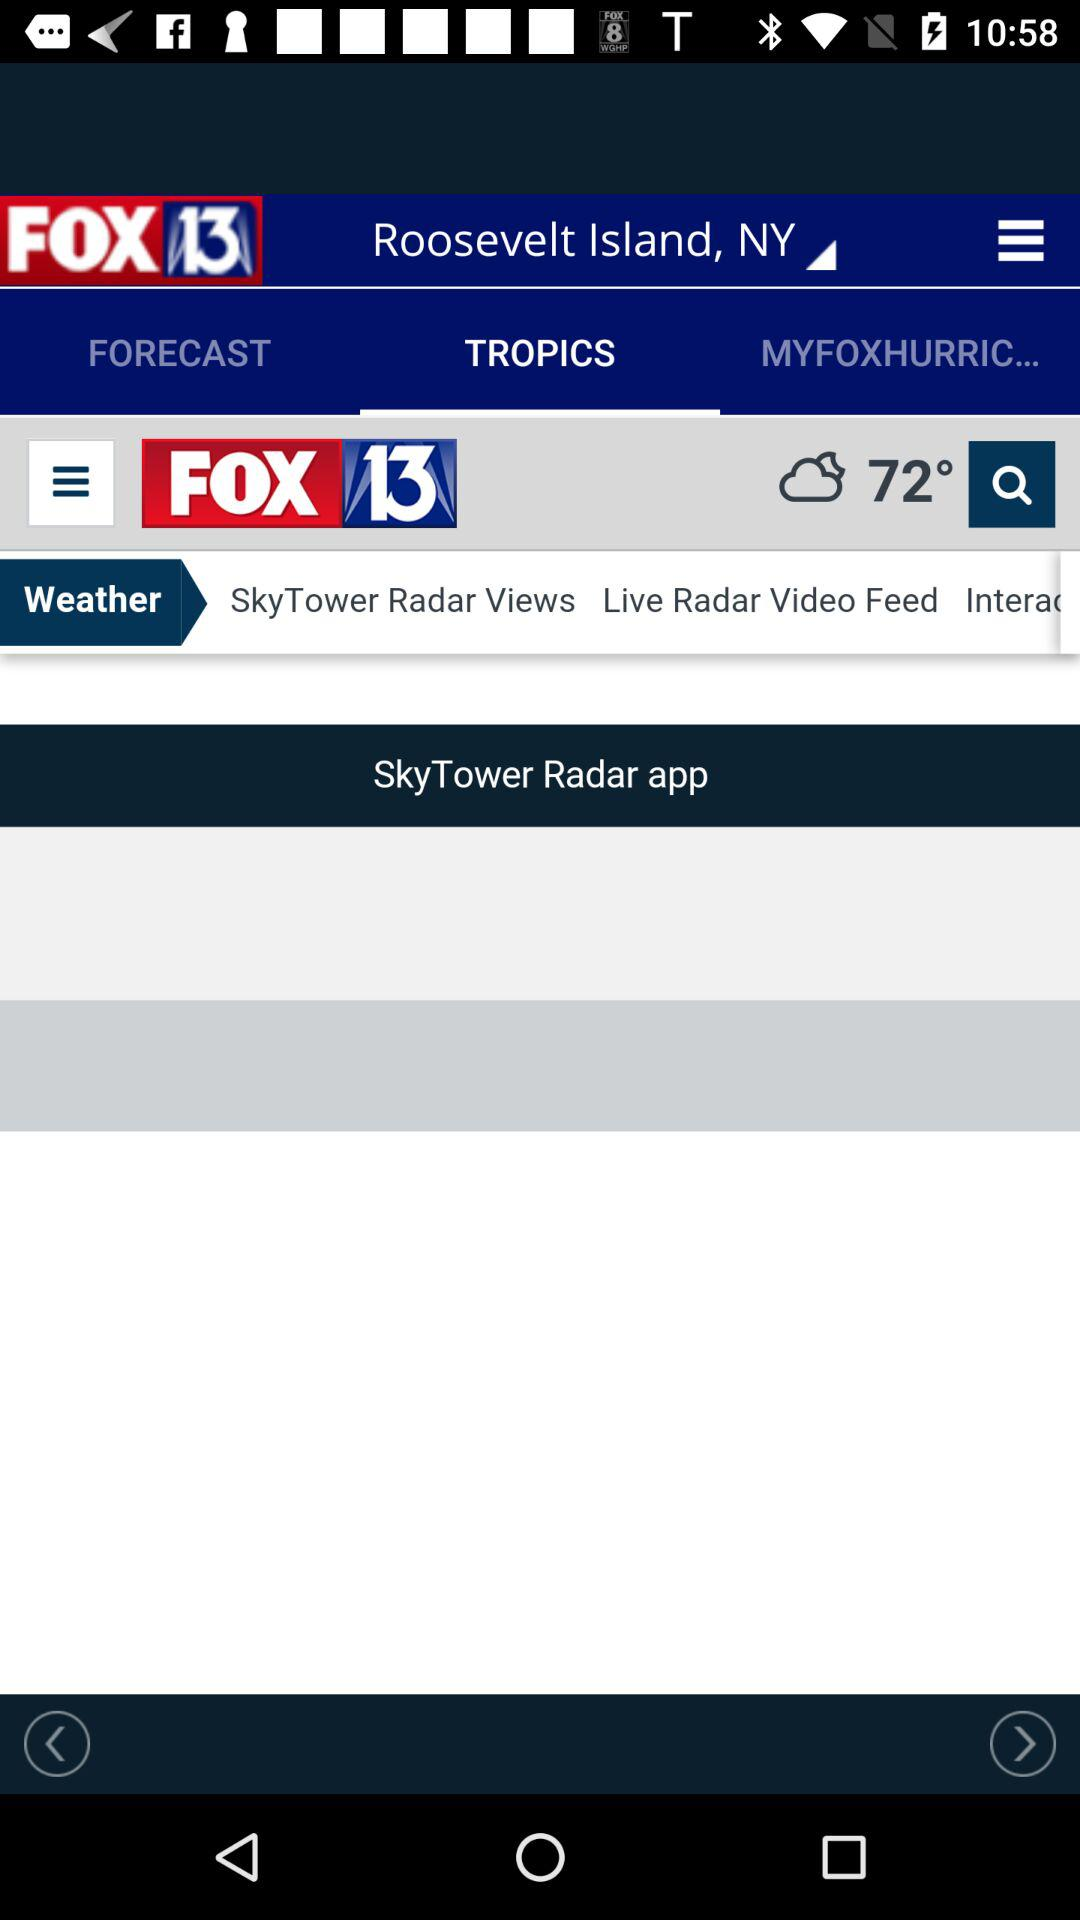What is the temperature? The temperature is 72°. 